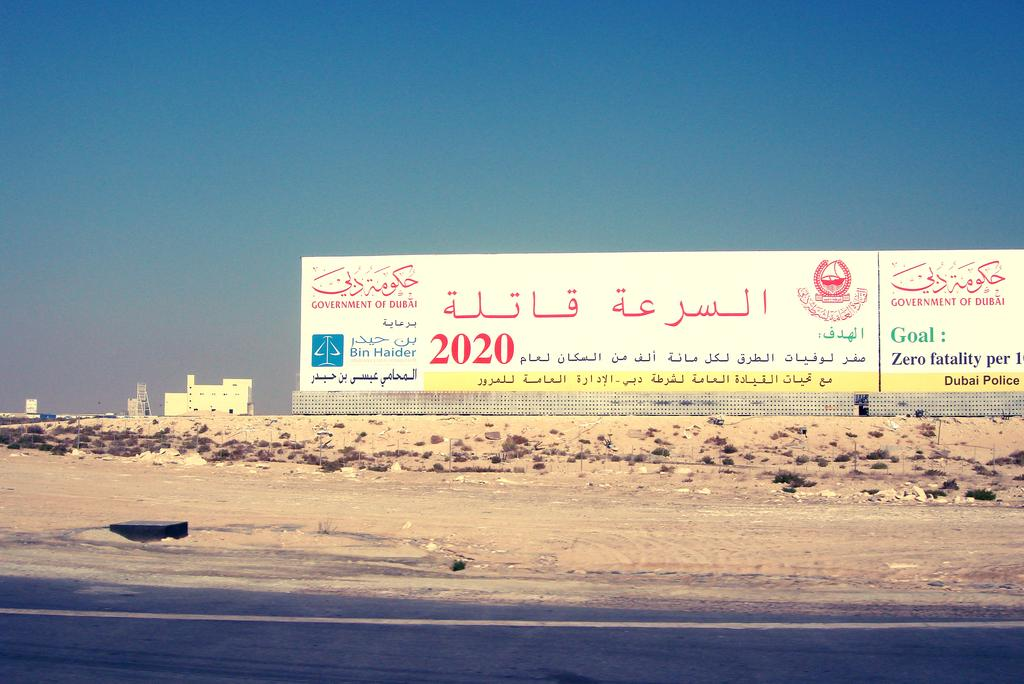What is the main structure featured in the image? There is a hoarding in the image. What else can be seen in the image besides the hoarding? There are buildings, the ground, poles, trees, a road, and the sky visible in the image. Can you describe the road in the image? The road is at the bottom of the image. What type of vegetation is present in the image? There are trees in the image. How does the police officer help with the knowledge in the image? There is no police officer present in the image, so it is not possible to answer that question. 